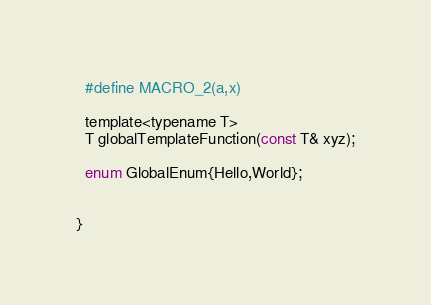Convert code to text. <code><loc_0><loc_0><loc_500><loc_500><_C_>  #define MACRO_2(a,x)
  
  template<typename T>
  T globalTemplateFunction(const T& xyz);
  
  enum GlobalEnum{Hello,World};
  
  
}

</code> 